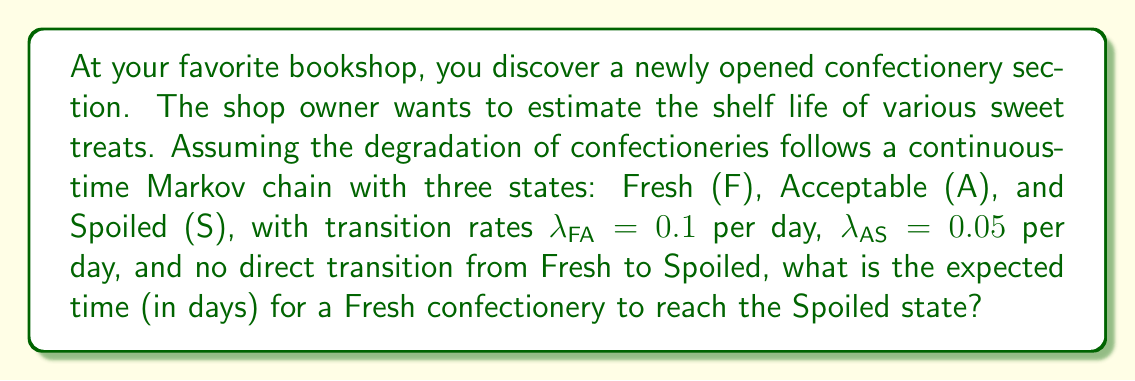What is the answer to this math problem? To solve this problem, we'll use the properties of continuous-time Markov chains and the concept of mean first passage time.

Step 1: Set up the transition rate matrix Q.
$$Q = \begin{bmatrix}
-0.1 & 0.1 & 0 \\
0 & -0.05 & 0.05 \\
0 & 0 & 0
\end{bmatrix}$$

Step 2: Calculate the fundamental matrix N.
First, remove the absorbing state (Spoiled) and create the transient rate matrix:
$$Q_T = \begin{bmatrix}
-0.1 & 0.1 \\
0 & -0.05
\end{bmatrix}$$

Then, calculate N = -Q_T^(-1):
$$N = -\begin{bmatrix}
-0.1 & 0.1 \\
0 & -0.05
\end{bmatrix}^{-1} = \begin{bmatrix}
10 & 20 \\
0 & 20
\end{bmatrix}$$

Step 3: Calculate the expected time to absorption (spoilage) from the Fresh state.
The expected time is the sum of the first row of N:

Expected time = 10 + 20 = 30 days

This means that, on average, it takes 30 days for a Fresh confectionery to reach the Spoiled state.
Answer: 30 days 